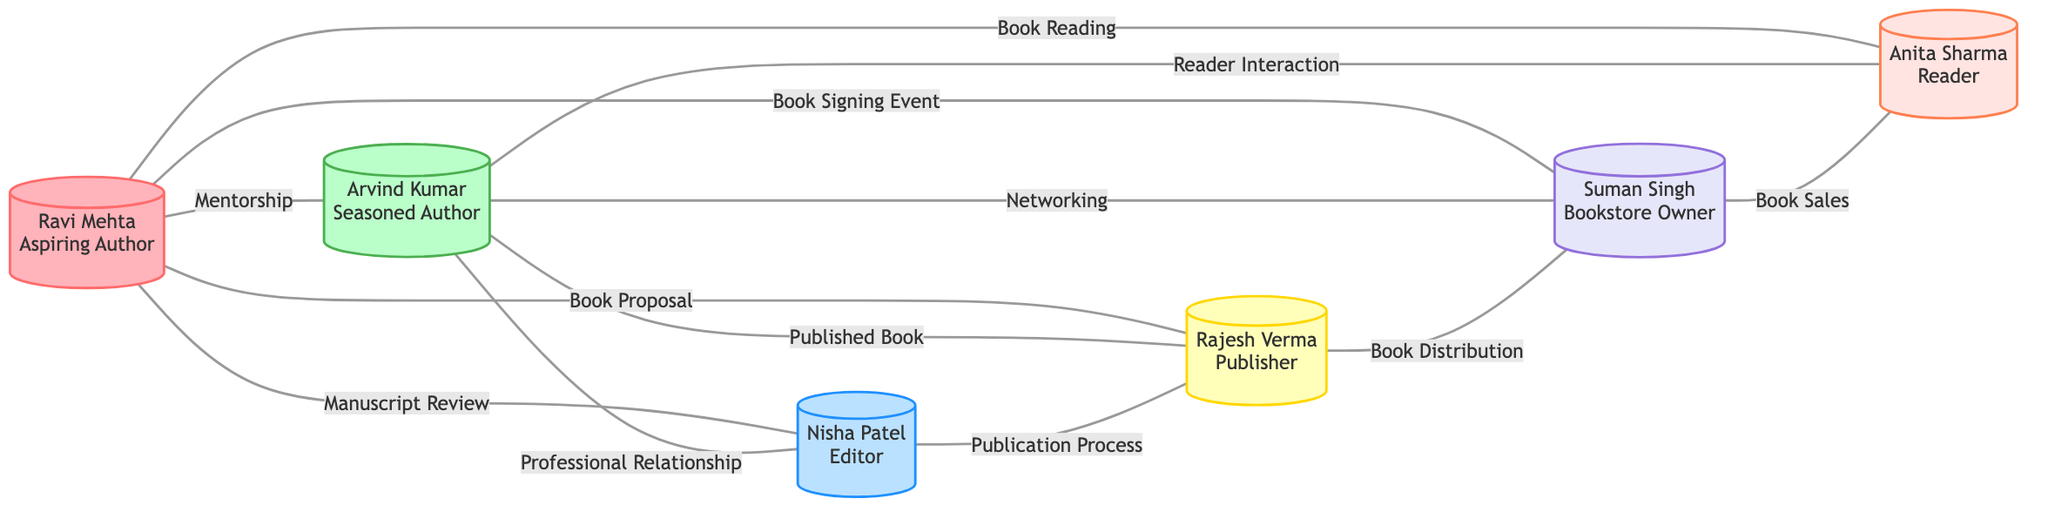What is the total number of nodes in the graph? The nodes are listed in the data section: Aspiring Author, Seasoned Author, Editor, Publisher, Bookstore Owner, and Reader. Counting them gives us 6 nodes in total.
Answer: 6 How many edges connect Ravi Mehta to other participants? The edges involving Ravi Mehta show connections to 5 participants: Arvind Kumar, Nisha Patel, Rajesh Verma, Suman Singh, and Anita Sharma. Counting these gives us 5 edges.
Answer: 5 What relationship connects Arvind Kumar and Nisha Patel? The relationship between Arvind Kumar (seasoned author) and Nisha Patel (editor) is specified as a Professional Relationship. This is indicated by the edge connecting the two nodes.
Answer: Professional Relationship Which node has the most relationships? To determine this, we need to count the number of edges connected to each node. Looking at the connections, we see that Arvind Kumar connects to 4 participants, while others have fewer. Therefore, Arvind Kumar has the most relationships in the graph.
Answer: Arvind Kumar What type of relationship exists between the Publisher and the Bookstore Owner? The edge connecting Rajesh Verma (Publisher) and Suman Singh (Bookstore Owner) is labeled as Book Distribution, indicating the type of relationship.
Answer: Book Distribution How many reader interactions are shown in the graph? The graph shows 2 instances of reader interactions: one between Arvind Kumar and Anita Sharma, and another between Ravi Mehta and Anita Sharma. So, adding these gives us 2 reader interactions.
Answer: 2 What is the relationship that Ravi Mehta has with the Editor? The edge connecting Ravi Mehta (Aspiring Author) and Nisha Patel (Editor) is labeled as Manuscript Review, indicating the specific relationship type between them.
Answer: Manuscript Review How many edges directly connect to the Bookstore Owner? Suman Singh (Bookstore Owner) connects to 3 other participants through edges: Ravi Mehta, Arvind Kumar, and Anita Sharma. Counting these edges gives us 3 connections.
Answer: 3 Which participant does not have a direct connection with Nisha Patel? By examining Nisha Patel's edges, we see no direct connection with Suman Singh, as there is no edge connecting these two participants.
Answer: Suman Singh 